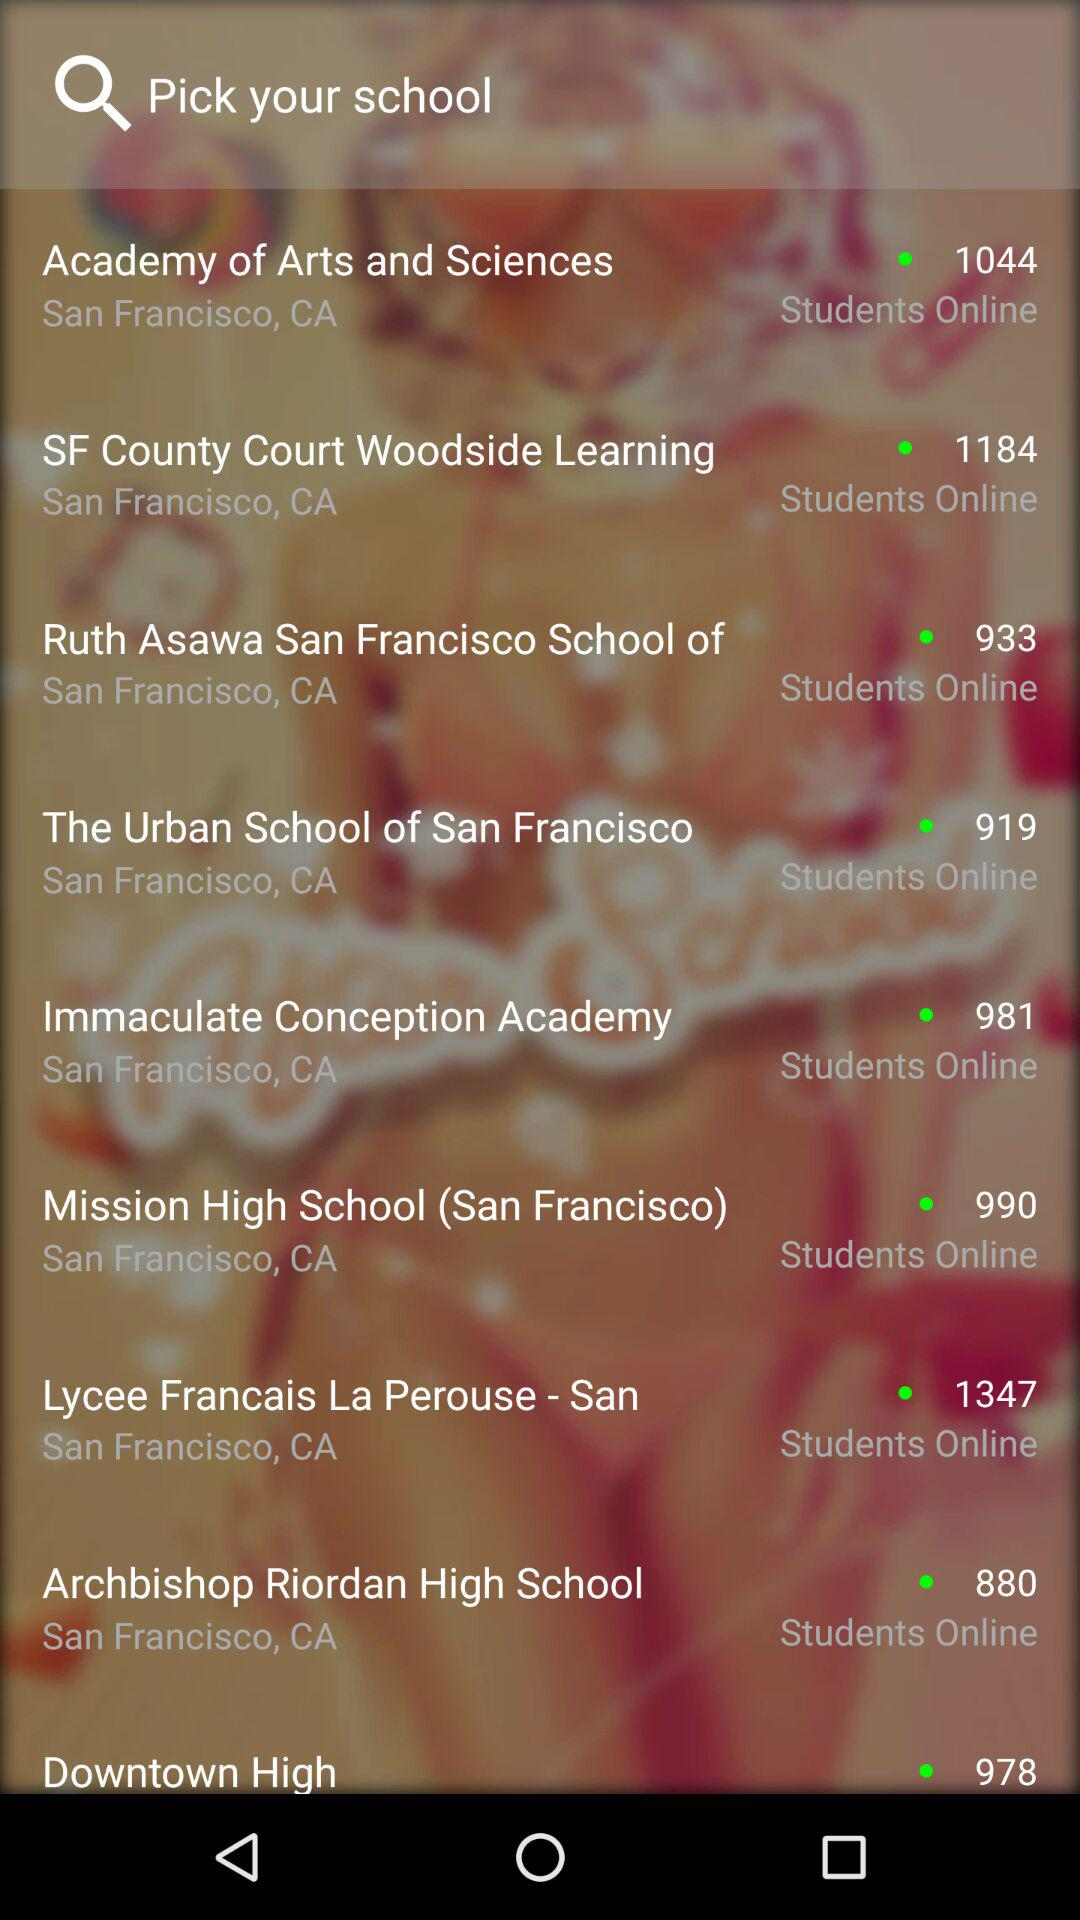What is the location of the "Ruth Asawa" school? The location is San Francisco, CA. 